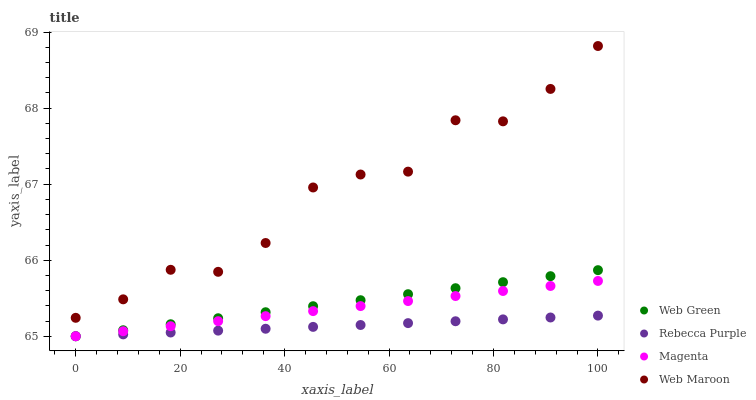Does Rebecca Purple have the minimum area under the curve?
Answer yes or no. Yes. Does Web Maroon have the maximum area under the curve?
Answer yes or no. Yes. Does Web Maroon have the minimum area under the curve?
Answer yes or no. No. Does Rebecca Purple have the maximum area under the curve?
Answer yes or no. No. Is Web Green the smoothest?
Answer yes or no. Yes. Is Web Maroon the roughest?
Answer yes or no. Yes. Is Rebecca Purple the smoothest?
Answer yes or no. No. Is Rebecca Purple the roughest?
Answer yes or no. No. Does Magenta have the lowest value?
Answer yes or no. Yes. Does Web Maroon have the lowest value?
Answer yes or no. No. Does Web Maroon have the highest value?
Answer yes or no. Yes. Does Rebecca Purple have the highest value?
Answer yes or no. No. Is Rebecca Purple less than Web Maroon?
Answer yes or no. Yes. Is Web Maroon greater than Magenta?
Answer yes or no. Yes. Does Rebecca Purple intersect Magenta?
Answer yes or no. Yes. Is Rebecca Purple less than Magenta?
Answer yes or no. No. Is Rebecca Purple greater than Magenta?
Answer yes or no. No. Does Rebecca Purple intersect Web Maroon?
Answer yes or no. No. 